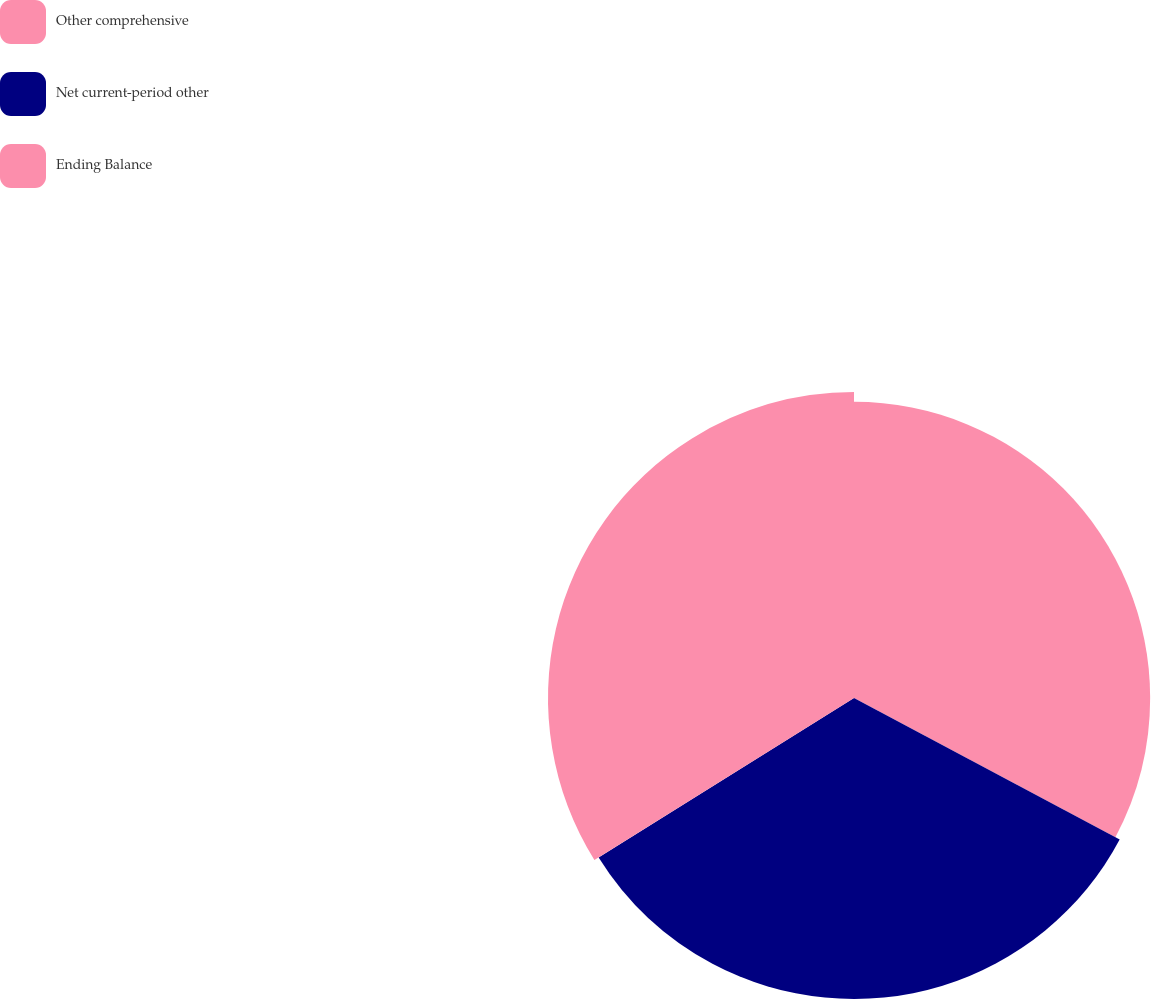Convert chart to OTSL. <chart><loc_0><loc_0><loc_500><loc_500><pie_chart><fcel>Other comprehensive<fcel>Net current-period other<fcel>Ending Balance<nl><fcel>32.79%<fcel>33.33%<fcel>33.88%<nl></chart> 